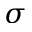Convert formula to latex. <formula><loc_0><loc_0><loc_500><loc_500>\sigma</formula> 